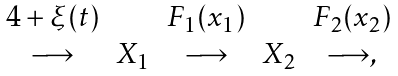Convert formula to latex. <formula><loc_0><loc_0><loc_500><loc_500>\begin{array} { c c c c c c } 4 + \xi ( t ) & & F _ { 1 } ( x _ { 1 } ) & & F _ { 2 } ( x _ { 2 } ) & \\ \longrightarrow & X _ { 1 } & \longrightarrow & X _ { 2 } & \longrightarrow , \end{array}</formula> 